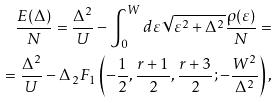<formula> <loc_0><loc_0><loc_500><loc_500>\frac { E ( \Delta ) } { N } = \frac { \Delta ^ { 2 } } { U } - \int _ { 0 } ^ { W } d \varepsilon \sqrt { \varepsilon ^ { 2 } + \Delta ^ { 2 } } \frac { \rho ( \varepsilon ) } { N } = \\ = \frac { \Delta ^ { 2 } } { U } - \Delta \, _ { 2 } F _ { 1 } \left ( - \frac { 1 } { 2 } , \frac { r + 1 } { 2 } , \frac { r + 3 } { 2 } ; - \frac { W ^ { 2 } } { \Delta ^ { 2 } } \right ) ,</formula> 